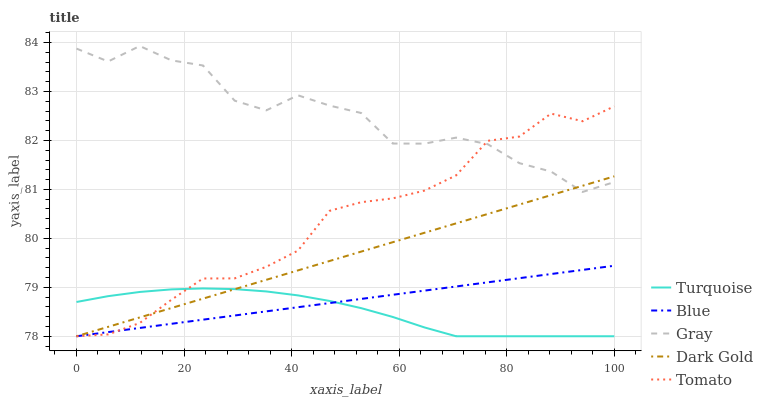Does Turquoise have the minimum area under the curve?
Answer yes or no. Yes. Does Gray have the maximum area under the curve?
Answer yes or no. Yes. Does Gray have the minimum area under the curve?
Answer yes or no. No. Does Turquoise have the maximum area under the curve?
Answer yes or no. No. Is Blue the smoothest?
Answer yes or no. Yes. Is Gray the roughest?
Answer yes or no. Yes. Is Turquoise the smoothest?
Answer yes or no. No. Is Turquoise the roughest?
Answer yes or no. No. Does Blue have the lowest value?
Answer yes or no. Yes. Does Gray have the lowest value?
Answer yes or no. No. Does Gray have the highest value?
Answer yes or no. Yes. Does Turquoise have the highest value?
Answer yes or no. No. Is Turquoise less than Gray?
Answer yes or no. Yes. Is Gray greater than Turquoise?
Answer yes or no. Yes. Does Tomato intersect Blue?
Answer yes or no. Yes. Is Tomato less than Blue?
Answer yes or no. No. Is Tomato greater than Blue?
Answer yes or no. No. Does Turquoise intersect Gray?
Answer yes or no. No. 